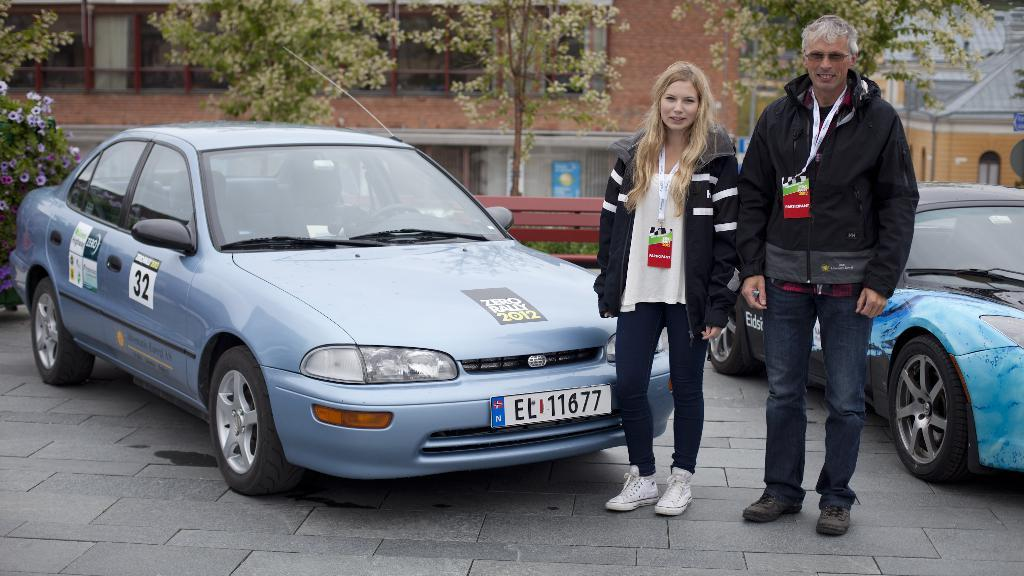How many people are present in the image? There are 2 people standing in the image. What is located behind the people? There are 2 cars behind the people. What type of seating is visible in the image? There is a bench in the image. What type of vegetation can be seen in the image? There are trees in the image. What type of structures are visible in the image? There are buildings in the image. What color is the grape that the person is holding in the image? There is no grape present in the image, and therefore no such activity can be observed. How does the person's breath affect the image? There is no mention of the person's breath in the image, so it cannot be determined how it affects the image. 